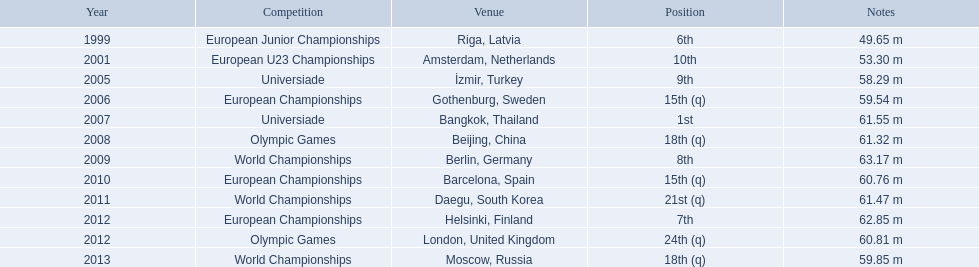What are the various competitions? European Junior Championships, European U23 Championships, Universiade, European Championships, Universiade, Olympic Games, World Championships, European Championships, World Championships, European Championships, Olympic Games, World Championships. In what years did they finish in the top 10? 1999, 2001, 2005, 2007, 2009, 2012. Parse the table in full. {'header': ['Year', 'Competition', 'Venue', 'Position', 'Notes'], 'rows': [['1999', 'European Junior Championships', 'Riga, Latvia', '6th', '49.65 m'], ['2001', 'European U23 Championships', 'Amsterdam, Netherlands', '10th', '53.30 m'], ['2005', 'Universiade', 'İzmir, Turkey', '9th', '58.29 m'], ['2006', 'European Championships', 'Gothenburg, Sweden', '15th (q)', '59.54 m'], ['2007', 'Universiade', 'Bangkok, Thailand', '1st', '61.55 m'], ['2008', 'Olympic Games', 'Beijing, China', '18th (q)', '61.32 m'], ['2009', 'World Championships', 'Berlin, Germany', '8th', '63.17 m'], ['2010', 'European Championships', 'Barcelona, Spain', '15th (q)', '60.76 m'], ['2011', 'World Championships', 'Daegu, South Korea', '21st (q)', '61.47 m'], ['2012', 'European Championships', 'Helsinki, Finland', '7th', '62.85 m'], ['2012', 'Olympic Games', 'London, United Kingdom', '24th (q)', '60.81 m'], ['2013', 'World Championships', 'Moscow, Russia', '18th (q)', '59.85 m']]} Excluding when they achieved first place, what was their top placement? 6th. 